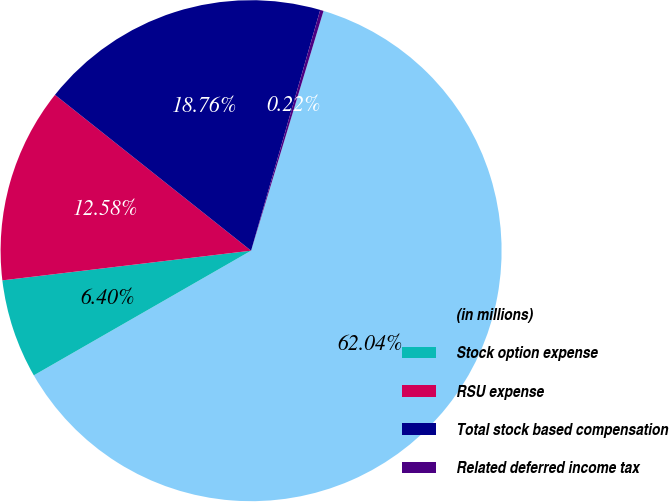<chart> <loc_0><loc_0><loc_500><loc_500><pie_chart><fcel>(in millions)<fcel>Stock option expense<fcel>RSU expense<fcel>Total stock based compensation<fcel>Related deferred income tax<nl><fcel>62.04%<fcel>6.4%<fcel>12.58%<fcel>18.76%<fcel>0.22%<nl></chart> 